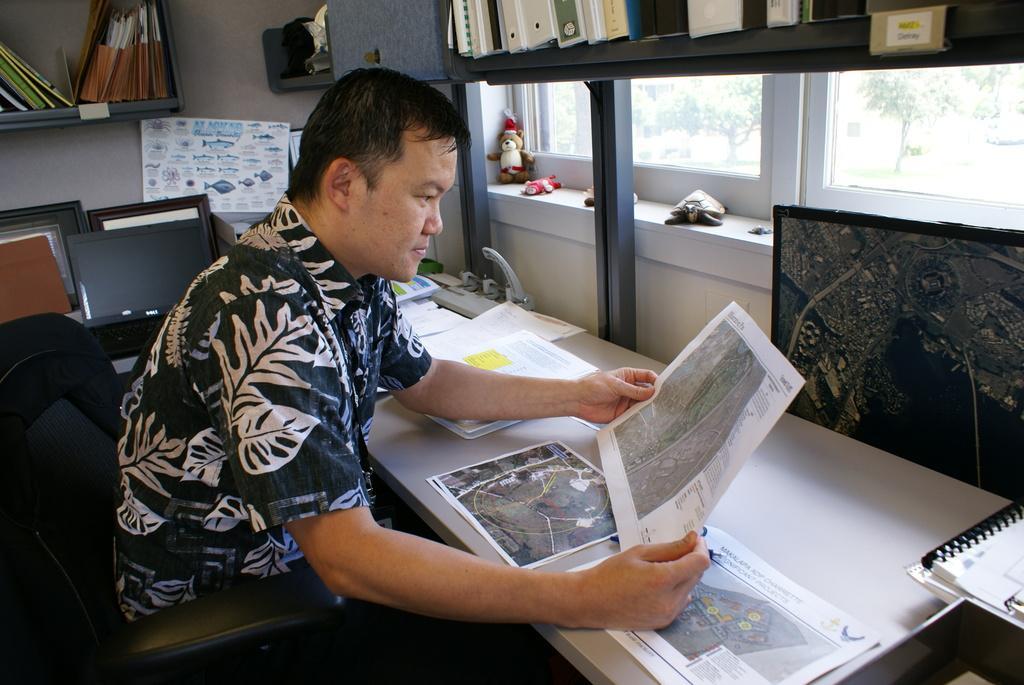Please provide a concise description of this image. In this image there is a man sitting on the chair and he is holding the paper and there is text on the paper. There are papers and there is an object and there are books on the table. At the back there are books in the shelf and there is an object and there are papers on the wall and there are toys on the wall and there are windows, behind the windows there is a building and there are trees. 